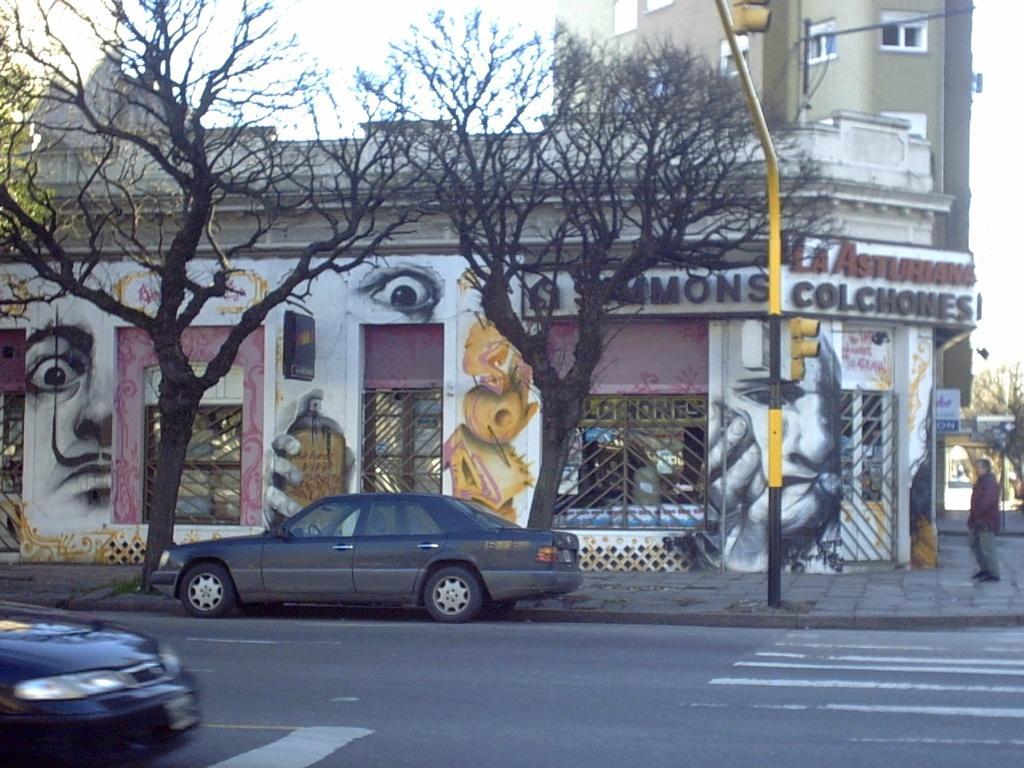Could you give a brief overview of what you see in this image? In this image we can see few stores. There are few paintings on the wall. There are few trees in the image. There are few vehicles in the image. There is a person at the right side of the image. We can see the traffic lights at the top of the image. We can see the sky in the image. 